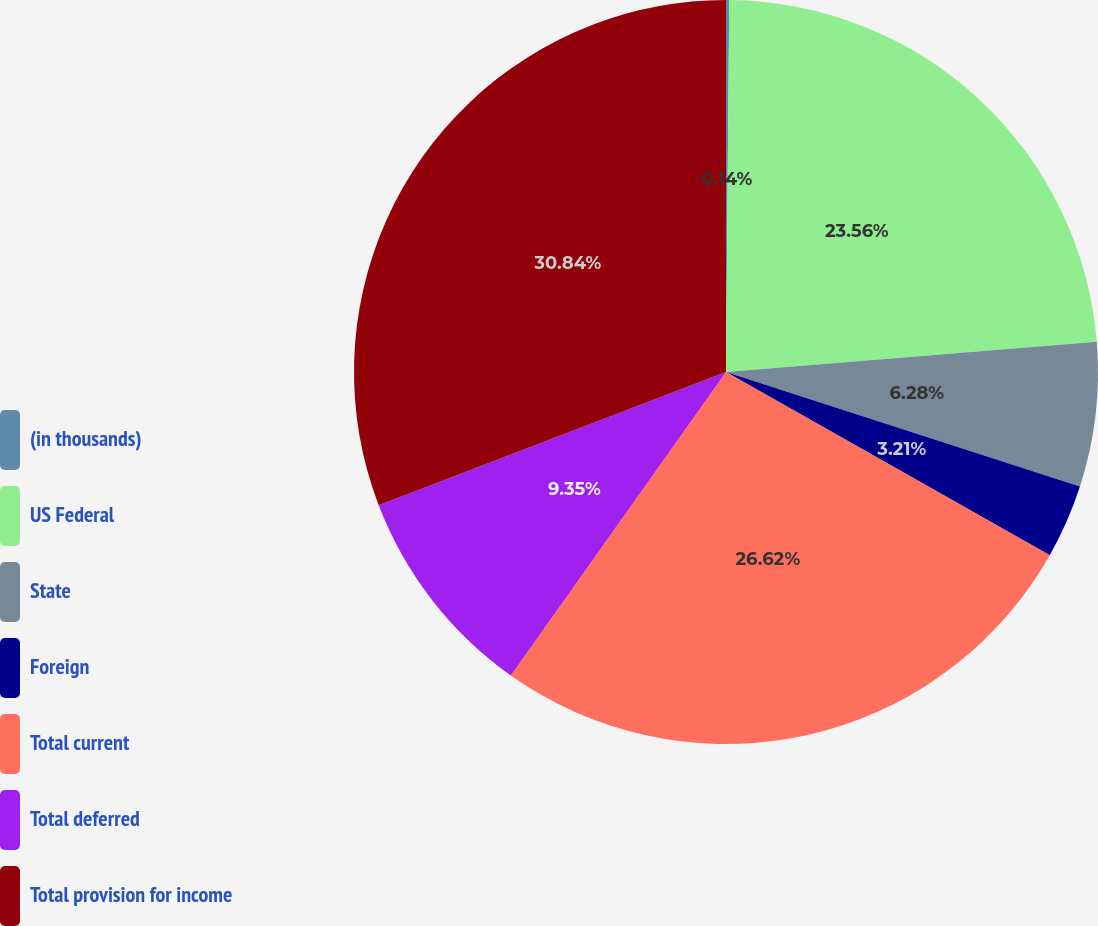<chart> <loc_0><loc_0><loc_500><loc_500><pie_chart><fcel>(in thousands)<fcel>US Federal<fcel>State<fcel>Foreign<fcel>Total current<fcel>Total deferred<fcel>Total provision for income<nl><fcel>0.14%<fcel>23.56%<fcel>6.28%<fcel>3.21%<fcel>26.62%<fcel>9.35%<fcel>30.83%<nl></chart> 